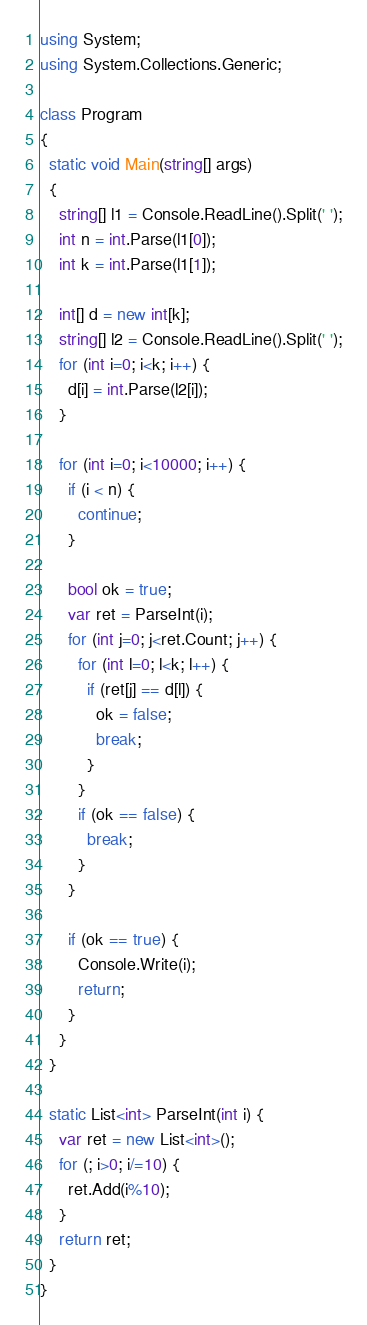Convert code to text. <code><loc_0><loc_0><loc_500><loc_500><_C#_>using System;
using System.Collections.Generic;

class Program
{
  static void Main(string[] args)
  {
    string[] l1 = Console.ReadLine().Split(' ');
    int n = int.Parse(l1[0]);
    int k = int.Parse(l1[1]);

    int[] d = new int[k];
    string[] l2 = Console.ReadLine().Split(' ');
    for (int i=0; i<k; i++) {
      d[i] = int.Parse(l2[i]);
    }

    for (int i=0; i<10000; i++) {
      if (i < n) {
        continue;
      }

      bool ok = true;
      var ret = ParseInt(i);
      for (int j=0; j<ret.Count; j++) {
        for (int l=0; l<k; l++) {
          if (ret[j] == d[l]) {
            ok = false;
            break;
          }
        }
        if (ok == false) {
          break;
        }
      }

      if (ok == true) {
        Console.Write(i);
        return;
      }
    }
  }

  static List<int> ParseInt(int i) {
    var ret = new List<int>();
    for (; i>0; i/=10) {
      ret.Add(i%10);
    }
    return ret;
  }
}
</code> 